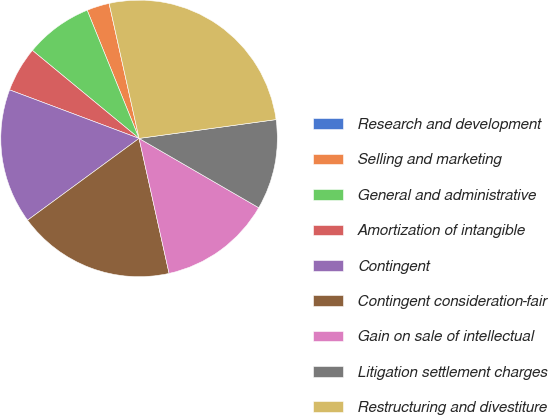Convert chart. <chart><loc_0><loc_0><loc_500><loc_500><pie_chart><fcel>Research and development<fcel>Selling and marketing<fcel>General and administrative<fcel>Amortization of intangible<fcel>Contingent<fcel>Contingent consideration-fair<fcel>Gain on sale of intellectual<fcel>Litigation settlement charges<fcel>Restructuring and divestiture<nl><fcel>0.01%<fcel>2.64%<fcel>7.9%<fcel>5.27%<fcel>15.78%<fcel>18.41%<fcel>13.16%<fcel>10.53%<fcel>26.3%<nl></chart> 